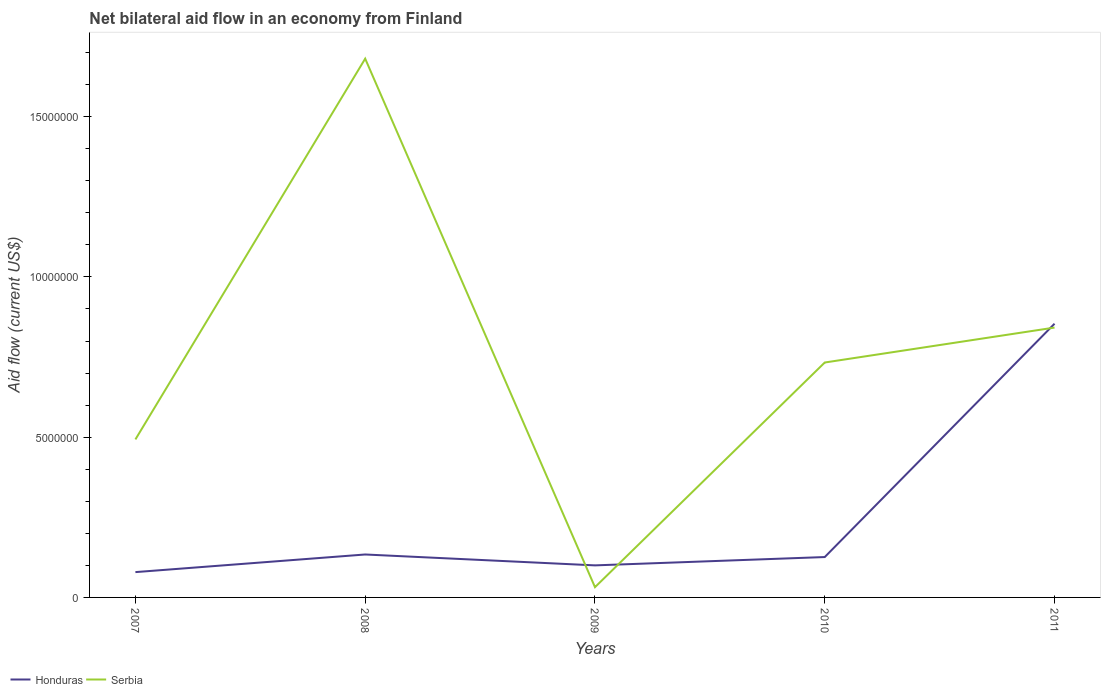How many different coloured lines are there?
Your answer should be compact. 2. Across all years, what is the maximum net bilateral aid flow in Serbia?
Make the answer very short. 3.20e+05. What is the total net bilateral aid flow in Serbia in the graph?
Provide a short and direct response. -7.01e+06. What is the difference between the highest and the second highest net bilateral aid flow in Honduras?
Offer a terse response. 7.75e+06. What is the difference between the highest and the lowest net bilateral aid flow in Honduras?
Offer a terse response. 1. Is the net bilateral aid flow in Serbia strictly greater than the net bilateral aid flow in Honduras over the years?
Your response must be concise. No. How many lines are there?
Ensure brevity in your answer.  2. What is the difference between two consecutive major ticks on the Y-axis?
Give a very brief answer. 5.00e+06. Does the graph contain any zero values?
Offer a terse response. No. Does the graph contain grids?
Provide a succinct answer. No. Where does the legend appear in the graph?
Offer a very short reply. Bottom left. What is the title of the graph?
Offer a very short reply. Net bilateral aid flow in an economy from Finland. What is the label or title of the X-axis?
Keep it short and to the point. Years. What is the label or title of the Y-axis?
Offer a very short reply. Aid flow (current US$). What is the Aid flow (current US$) in Honduras in 2007?
Keep it short and to the point. 7.90e+05. What is the Aid flow (current US$) in Serbia in 2007?
Provide a succinct answer. 4.93e+06. What is the Aid flow (current US$) of Honduras in 2008?
Make the answer very short. 1.34e+06. What is the Aid flow (current US$) of Serbia in 2008?
Provide a short and direct response. 1.68e+07. What is the Aid flow (current US$) of Honduras in 2009?
Provide a succinct answer. 1.00e+06. What is the Aid flow (current US$) of Honduras in 2010?
Give a very brief answer. 1.26e+06. What is the Aid flow (current US$) in Serbia in 2010?
Offer a terse response. 7.33e+06. What is the Aid flow (current US$) in Honduras in 2011?
Offer a terse response. 8.54e+06. What is the Aid flow (current US$) in Serbia in 2011?
Your answer should be compact. 8.42e+06. Across all years, what is the maximum Aid flow (current US$) of Honduras?
Your answer should be very brief. 8.54e+06. Across all years, what is the maximum Aid flow (current US$) of Serbia?
Your response must be concise. 1.68e+07. Across all years, what is the minimum Aid flow (current US$) of Honduras?
Give a very brief answer. 7.90e+05. What is the total Aid flow (current US$) of Honduras in the graph?
Give a very brief answer. 1.29e+07. What is the total Aid flow (current US$) in Serbia in the graph?
Make the answer very short. 3.78e+07. What is the difference between the Aid flow (current US$) of Honduras in 2007 and that in 2008?
Ensure brevity in your answer.  -5.50e+05. What is the difference between the Aid flow (current US$) of Serbia in 2007 and that in 2008?
Your response must be concise. -1.19e+07. What is the difference between the Aid flow (current US$) of Honduras in 2007 and that in 2009?
Keep it short and to the point. -2.10e+05. What is the difference between the Aid flow (current US$) in Serbia in 2007 and that in 2009?
Keep it short and to the point. 4.61e+06. What is the difference between the Aid flow (current US$) of Honduras in 2007 and that in 2010?
Give a very brief answer. -4.70e+05. What is the difference between the Aid flow (current US$) in Serbia in 2007 and that in 2010?
Make the answer very short. -2.40e+06. What is the difference between the Aid flow (current US$) in Honduras in 2007 and that in 2011?
Offer a very short reply. -7.75e+06. What is the difference between the Aid flow (current US$) in Serbia in 2007 and that in 2011?
Your response must be concise. -3.49e+06. What is the difference between the Aid flow (current US$) in Serbia in 2008 and that in 2009?
Ensure brevity in your answer.  1.65e+07. What is the difference between the Aid flow (current US$) in Serbia in 2008 and that in 2010?
Keep it short and to the point. 9.48e+06. What is the difference between the Aid flow (current US$) of Honduras in 2008 and that in 2011?
Provide a short and direct response. -7.20e+06. What is the difference between the Aid flow (current US$) of Serbia in 2008 and that in 2011?
Your response must be concise. 8.39e+06. What is the difference between the Aid flow (current US$) of Honduras in 2009 and that in 2010?
Offer a terse response. -2.60e+05. What is the difference between the Aid flow (current US$) in Serbia in 2009 and that in 2010?
Keep it short and to the point. -7.01e+06. What is the difference between the Aid flow (current US$) in Honduras in 2009 and that in 2011?
Keep it short and to the point. -7.54e+06. What is the difference between the Aid flow (current US$) of Serbia in 2009 and that in 2011?
Make the answer very short. -8.10e+06. What is the difference between the Aid flow (current US$) of Honduras in 2010 and that in 2011?
Your answer should be very brief. -7.28e+06. What is the difference between the Aid flow (current US$) of Serbia in 2010 and that in 2011?
Offer a very short reply. -1.09e+06. What is the difference between the Aid flow (current US$) in Honduras in 2007 and the Aid flow (current US$) in Serbia in 2008?
Your response must be concise. -1.60e+07. What is the difference between the Aid flow (current US$) of Honduras in 2007 and the Aid flow (current US$) of Serbia in 2009?
Your answer should be compact. 4.70e+05. What is the difference between the Aid flow (current US$) in Honduras in 2007 and the Aid flow (current US$) in Serbia in 2010?
Offer a very short reply. -6.54e+06. What is the difference between the Aid flow (current US$) of Honduras in 2007 and the Aid flow (current US$) of Serbia in 2011?
Make the answer very short. -7.63e+06. What is the difference between the Aid flow (current US$) in Honduras in 2008 and the Aid flow (current US$) in Serbia in 2009?
Your answer should be compact. 1.02e+06. What is the difference between the Aid flow (current US$) in Honduras in 2008 and the Aid flow (current US$) in Serbia in 2010?
Your answer should be very brief. -5.99e+06. What is the difference between the Aid flow (current US$) in Honduras in 2008 and the Aid flow (current US$) in Serbia in 2011?
Give a very brief answer. -7.08e+06. What is the difference between the Aid flow (current US$) of Honduras in 2009 and the Aid flow (current US$) of Serbia in 2010?
Your response must be concise. -6.33e+06. What is the difference between the Aid flow (current US$) of Honduras in 2009 and the Aid flow (current US$) of Serbia in 2011?
Provide a succinct answer. -7.42e+06. What is the difference between the Aid flow (current US$) of Honduras in 2010 and the Aid flow (current US$) of Serbia in 2011?
Your answer should be compact. -7.16e+06. What is the average Aid flow (current US$) of Honduras per year?
Your response must be concise. 2.59e+06. What is the average Aid flow (current US$) in Serbia per year?
Offer a very short reply. 7.56e+06. In the year 2007, what is the difference between the Aid flow (current US$) of Honduras and Aid flow (current US$) of Serbia?
Make the answer very short. -4.14e+06. In the year 2008, what is the difference between the Aid flow (current US$) in Honduras and Aid flow (current US$) in Serbia?
Offer a terse response. -1.55e+07. In the year 2009, what is the difference between the Aid flow (current US$) of Honduras and Aid flow (current US$) of Serbia?
Provide a succinct answer. 6.80e+05. In the year 2010, what is the difference between the Aid flow (current US$) of Honduras and Aid flow (current US$) of Serbia?
Ensure brevity in your answer.  -6.07e+06. In the year 2011, what is the difference between the Aid flow (current US$) in Honduras and Aid flow (current US$) in Serbia?
Offer a very short reply. 1.20e+05. What is the ratio of the Aid flow (current US$) of Honduras in 2007 to that in 2008?
Provide a succinct answer. 0.59. What is the ratio of the Aid flow (current US$) of Serbia in 2007 to that in 2008?
Your answer should be very brief. 0.29. What is the ratio of the Aid flow (current US$) in Honduras in 2007 to that in 2009?
Your response must be concise. 0.79. What is the ratio of the Aid flow (current US$) in Serbia in 2007 to that in 2009?
Provide a short and direct response. 15.41. What is the ratio of the Aid flow (current US$) of Honduras in 2007 to that in 2010?
Provide a succinct answer. 0.63. What is the ratio of the Aid flow (current US$) in Serbia in 2007 to that in 2010?
Your answer should be compact. 0.67. What is the ratio of the Aid flow (current US$) of Honduras in 2007 to that in 2011?
Your response must be concise. 0.09. What is the ratio of the Aid flow (current US$) of Serbia in 2007 to that in 2011?
Your response must be concise. 0.59. What is the ratio of the Aid flow (current US$) in Honduras in 2008 to that in 2009?
Your response must be concise. 1.34. What is the ratio of the Aid flow (current US$) of Serbia in 2008 to that in 2009?
Keep it short and to the point. 52.53. What is the ratio of the Aid flow (current US$) in Honduras in 2008 to that in 2010?
Give a very brief answer. 1.06. What is the ratio of the Aid flow (current US$) in Serbia in 2008 to that in 2010?
Provide a succinct answer. 2.29. What is the ratio of the Aid flow (current US$) in Honduras in 2008 to that in 2011?
Ensure brevity in your answer.  0.16. What is the ratio of the Aid flow (current US$) of Serbia in 2008 to that in 2011?
Offer a terse response. 2. What is the ratio of the Aid flow (current US$) of Honduras in 2009 to that in 2010?
Give a very brief answer. 0.79. What is the ratio of the Aid flow (current US$) of Serbia in 2009 to that in 2010?
Your response must be concise. 0.04. What is the ratio of the Aid flow (current US$) in Honduras in 2009 to that in 2011?
Keep it short and to the point. 0.12. What is the ratio of the Aid flow (current US$) in Serbia in 2009 to that in 2011?
Your response must be concise. 0.04. What is the ratio of the Aid flow (current US$) in Honduras in 2010 to that in 2011?
Keep it short and to the point. 0.15. What is the ratio of the Aid flow (current US$) in Serbia in 2010 to that in 2011?
Provide a short and direct response. 0.87. What is the difference between the highest and the second highest Aid flow (current US$) in Honduras?
Ensure brevity in your answer.  7.20e+06. What is the difference between the highest and the second highest Aid flow (current US$) in Serbia?
Your answer should be compact. 8.39e+06. What is the difference between the highest and the lowest Aid flow (current US$) of Honduras?
Make the answer very short. 7.75e+06. What is the difference between the highest and the lowest Aid flow (current US$) of Serbia?
Make the answer very short. 1.65e+07. 